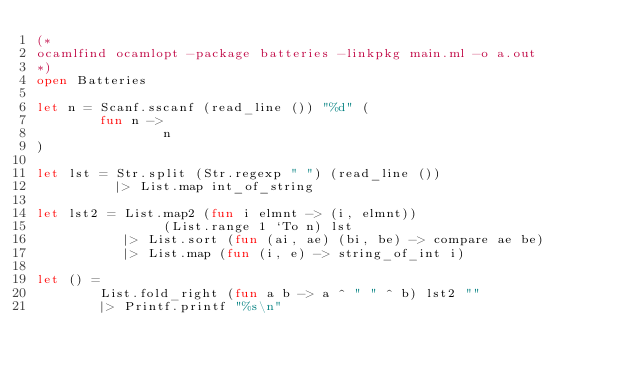Convert code to text. <code><loc_0><loc_0><loc_500><loc_500><_OCaml_>(*
ocamlfind ocamlopt -package batteries -linkpkg main.ml -o a.out
*)
open Batteries

let n = Scanf.sscanf (read_line ()) "%d" (
        fun n -> 
                n
)

let lst = Str.split (Str.regexp " ") (read_line ())
          |> List.map int_of_string

let lst2 = List.map2 (fun i elmnt -> (i, elmnt)) 
                (List.range 1 `To n) lst
           |> List.sort (fun (ai, ae) (bi, be) -> compare ae be)
           |> List.map (fun (i, e) -> string_of_int i)

let () = 
        List.fold_right (fun a b -> a ^ " " ^ b) lst2 ""
        |> Printf.printf "%s\n"

</code> 